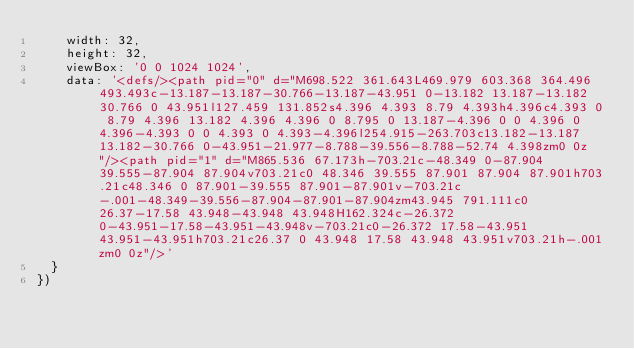Convert code to text. <code><loc_0><loc_0><loc_500><loc_500><_TypeScript_>    width: 32,
    height: 32,
    viewBox: '0 0 1024 1024',
    data: '<defs/><path pid="0" d="M698.522 361.643L469.979 603.368 364.496 493.493c-13.187-13.187-30.766-13.187-43.951 0-13.182 13.187-13.182 30.766 0 43.951l127.459 131.852s4.396 4.393 8.79 4.393h4.396c4.393 0 8.79 4.396 13.182 4.396 4.396 0 8.795 0 13.187-4.396 0 0 4.396 0 4.396-4.393 0 0 4.393 0 4.393-4.396l254.915-263.703c13.182-13.187 13.182-30.766 0-43.951-21.977-8.788-39.556-8.788-52.74 4.398zm0 0z"/><path pid="1" d="M865.536 67.173h-703.21c-48.349 0-87.904 39.555-87.904 87.904v703.21c0 48.346 39.555 87.901 87.904 87.901h703.21c48.346 0 87.901-39.555 87.901-87.901v-703.21c-.001-48.349-39.556-87.904-87.901-87.904zm43.945 791.111c0 26.37-17.58 43.948-43.948 43.948H162.324c-26.372 0-43.951-17.58-43.951-43.948v-703.21c0-26.372 17.58-43.951 43.951-43.951h703.21c26.37 0 43.948 17.58 43.948 43.951v703.21h-.001zm0 0z"/>'
  }
})
</code> 